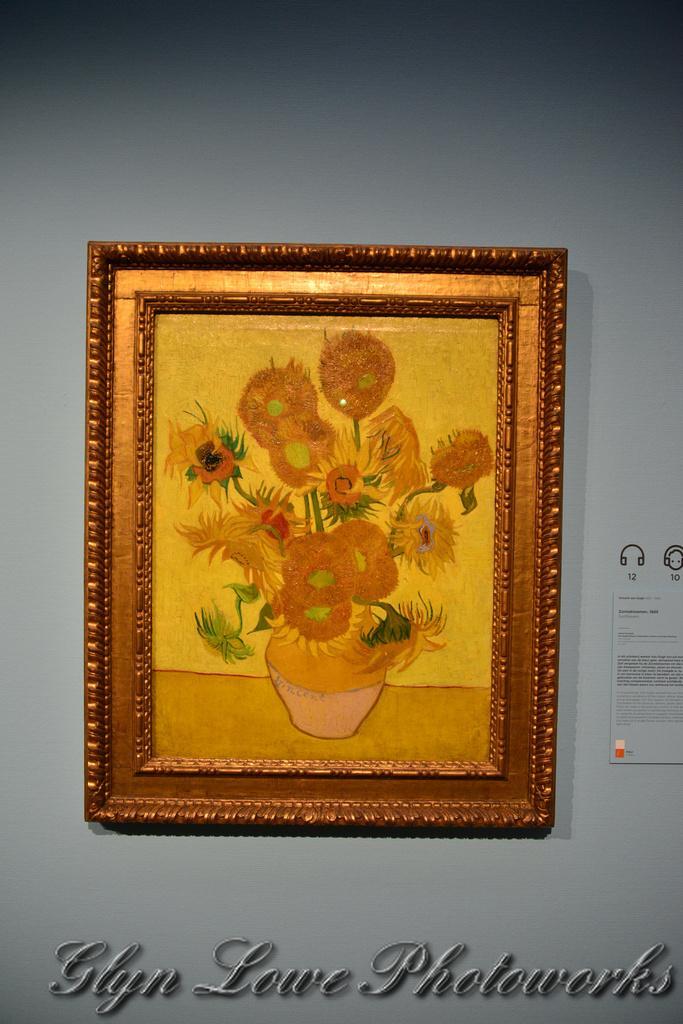Describe this image in one or two sentences. In this picture we can see a photo frame, poster on the wall, at the bottom we can see some text on it. 